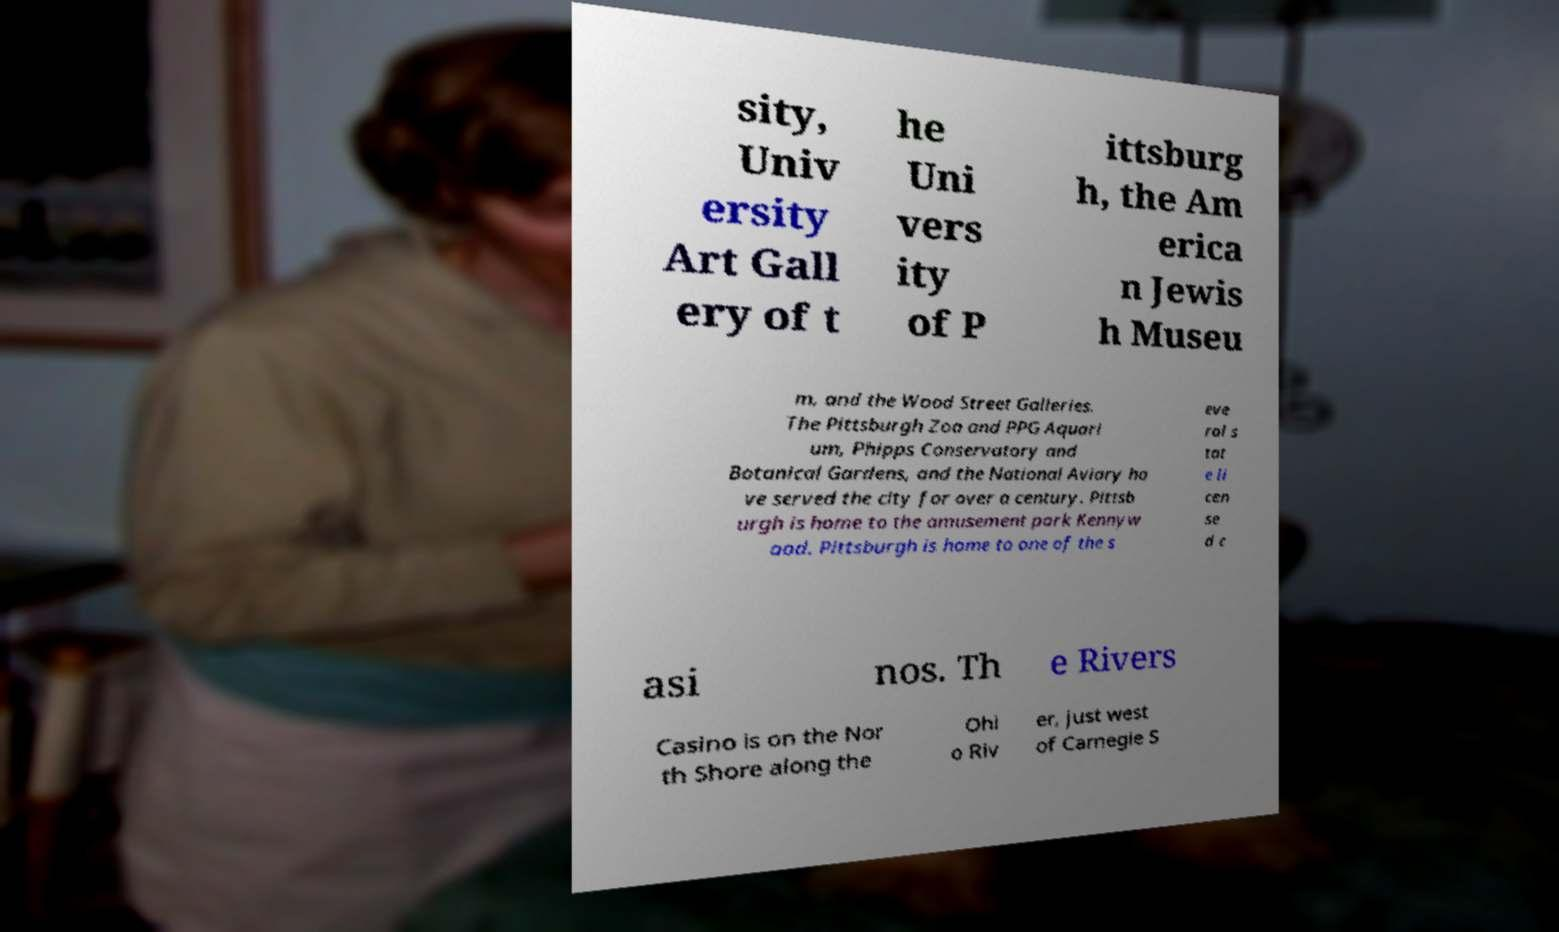What messages or text are displayed in this image? I need them in a readable, typed format. sity, Univ ersity Art Gall ery of t he Uni vers ity of P ittsburg h, the Am erica n Jewis h Museu m, and the Wood Street Galleries. The Pittsburgh Zoo and PPG Aquari um, Phipps Conservatory and Botanical Gardens, and the National Aviary ha ve served the city for over a century. Pittsb urgh is home to the amusement park Kennyw ood. Pittsburgh is home to one of the s eve ral s tat e li cen se d c asi nos. Th e Rivers Casino is on the Nor th Shore along the Ohi o Riv er, just west of Carnegie S 